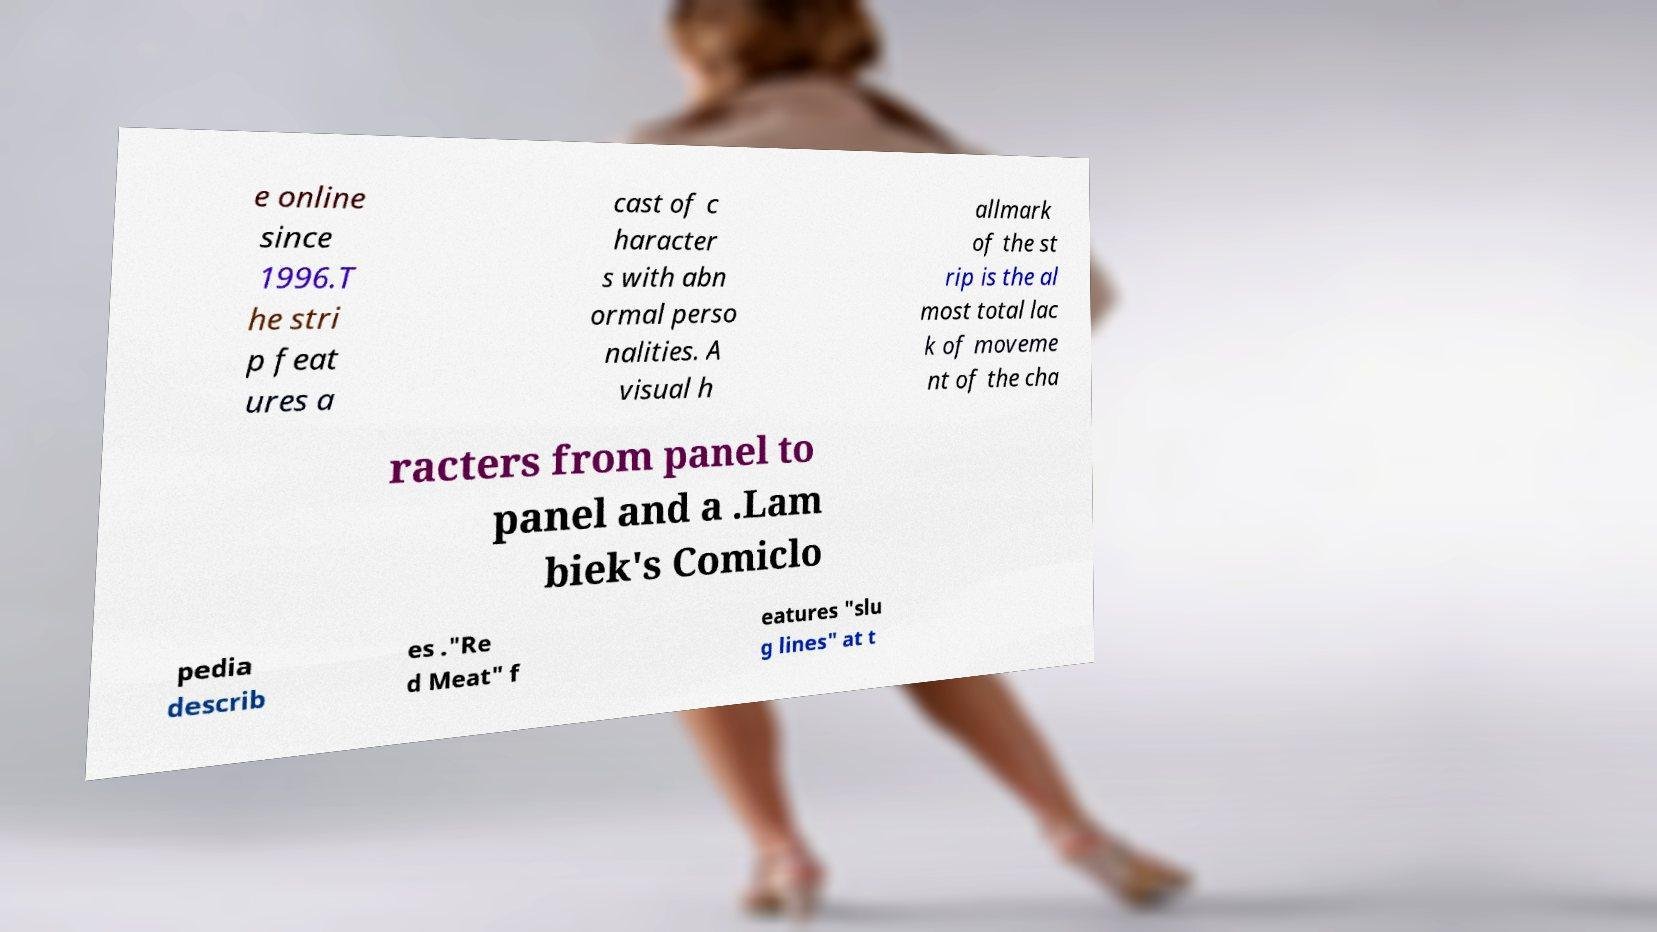Could you extract and type out the text from this image? e online since 1996.T he stri p feat ures a cast of c haracter s with abn ormal perso nalities. A visual h allmark of the st rip is the al most total lac k of moveme nt of the cha racters from panel to panel and a .Lam biek's Comiclo pedia describ es ."Re d Meat" f eatures "slu g lines" at t 